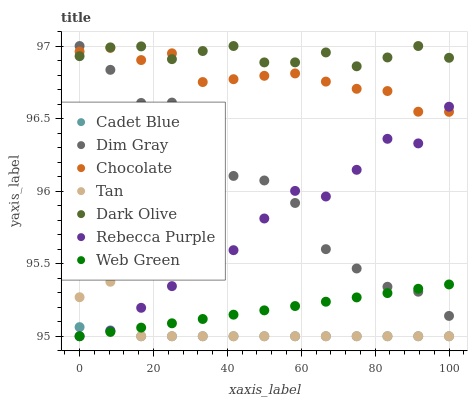Does Cadet Blue have the minimum area under the curve?
Answer yes or no. Yes. Does Dark Olive have the maximum area under the curve?
Answer yes or no. Yes. Does Web Green have the minimum area under the curve?
Answer yes or no. No. Does Web Green have the maximum area under the curve?
Answer yes or no. No. Is Web Green the smoothest?
Answer yes or no. Yes. Is Dim Gray the roughest?
Answer yes or no. Yes. Is Dark Olive the smoothest?
Answer yes or no. No. Is Dark Olive the roughest?
Answer yes or no. No. Does Web Green have the lowest value?
Answer yes or no. Yes. Does Dark Olive have the lowest value?
Answer yes or no. No. Does Dark Olive have the highest value?
Answer yes or no. Yes. Does Web Green have the highest value?
Answer yes or no. No. Is Cadet Blue less than Chocolate?
Answer yes or no. Yes. Is Dim Gray greater than Tan?
Answer yes or no. Yes. Does Rebecca Purple intersect Dim Gray?
Answer yes or no. Yes. Is Rebecca Purple less than Dim Gray?
Answer yes or no. No. Is Rebecca Purple greater than Dim Gray?
Answer yes or no. No. Does Cadet Blue intersect Chocolate?
Answer yes or no. No. 